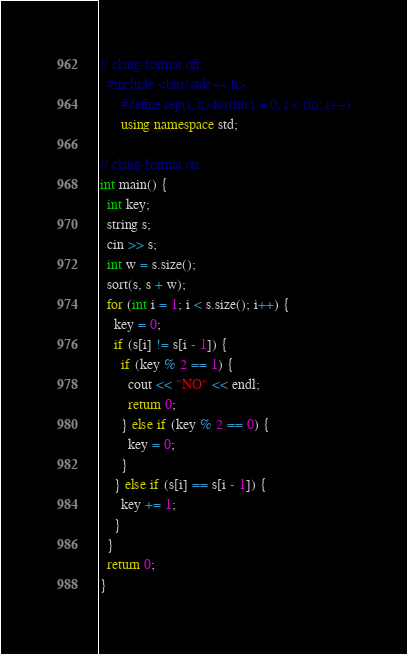<code> <loc_0><loc_0><loc_500><loc_500><_C++_>// clang-format off
  #include <bits/stdc++.h>
      #define rep(i, n) for(int i = 0; i < (n); i++)
      using namespace std;

// clang-format on
int main() {
  int key;
  string s;
  cin >> s;
  int w = s.size();
  sort(s, s + w);
  for (int i = 1; i < s.size(); i++) {
    key = 0;
    if (s[i] != s[i - 1]) {
      if (key % 2 == 1) {
        cout << "NO" << endl;
        return 0;
      } else if (key % 2 == 0) {
        key = 0;
      }
    } else if (s[i] == s[i - 1]) {
      key += 1;
    }
  }
  return 0;
}
</code> 